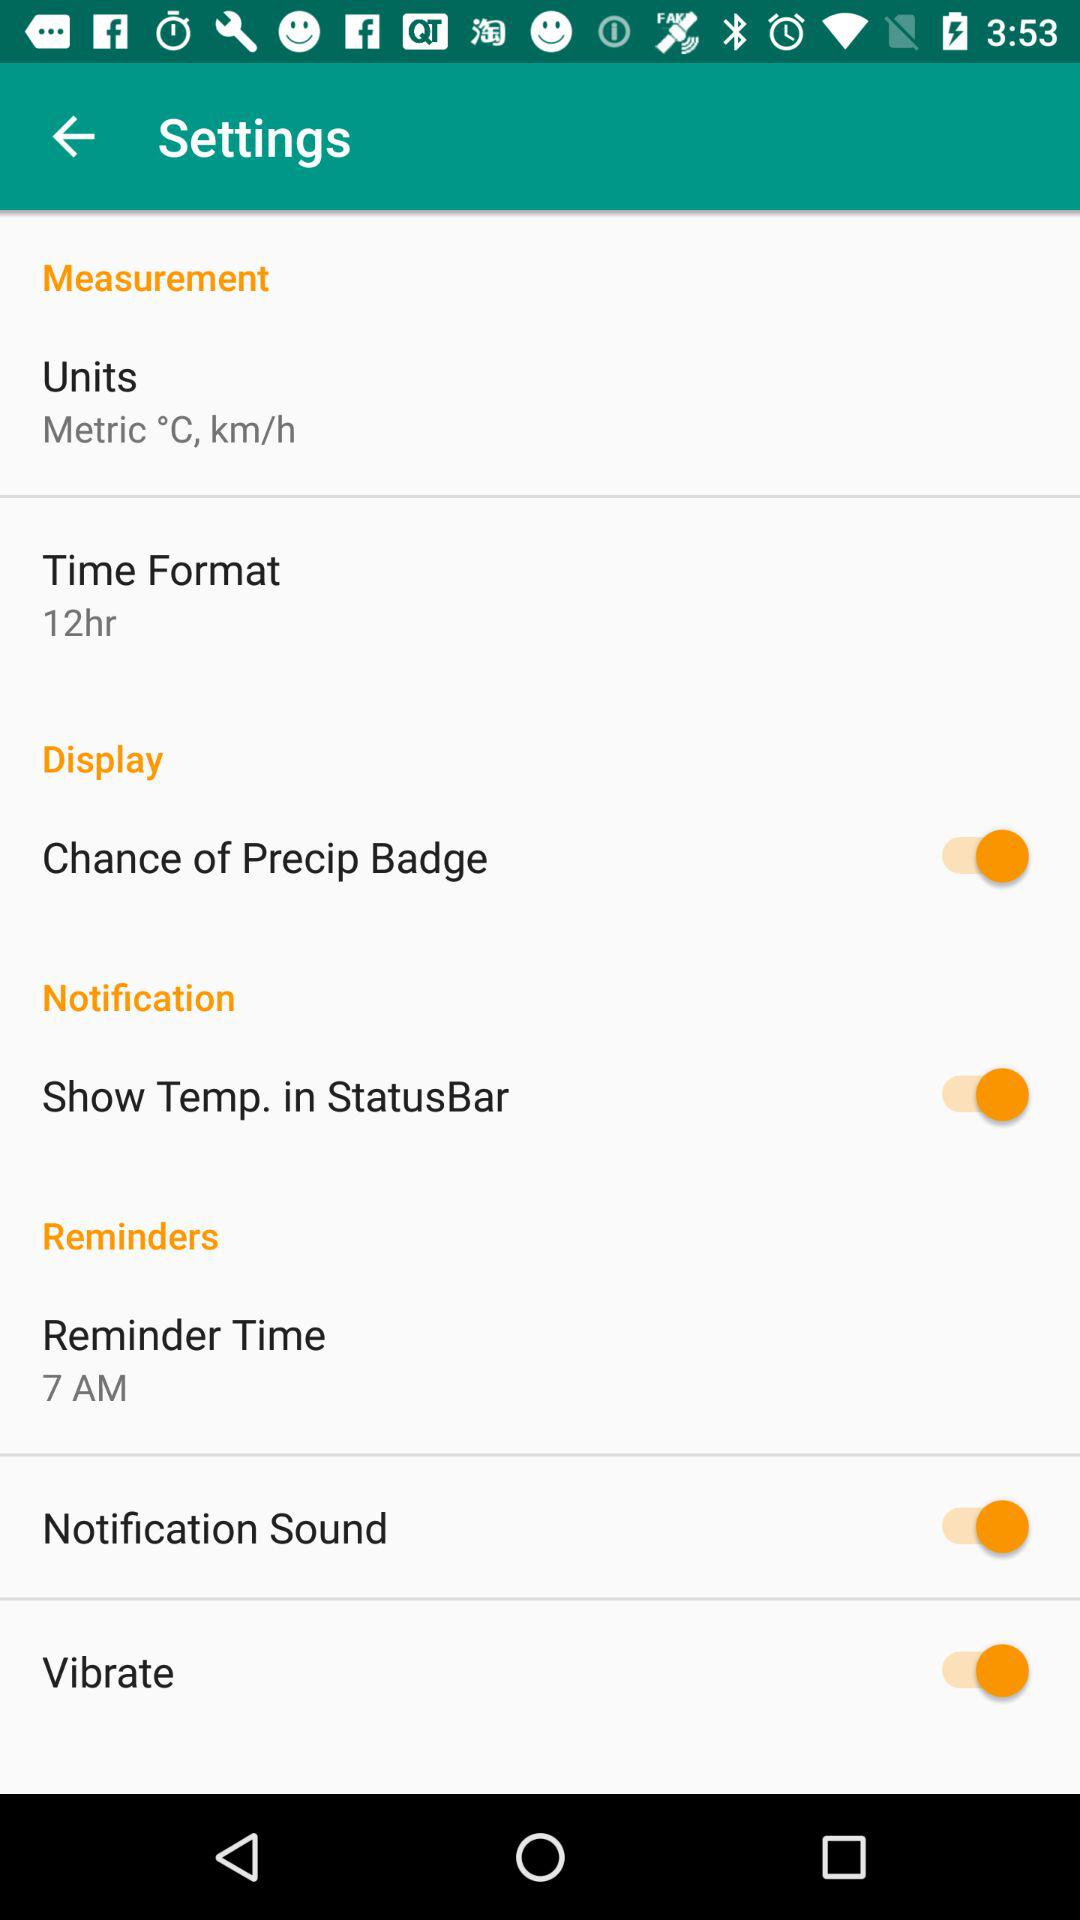What is the reminder time? The reminder time is 7 AM. 